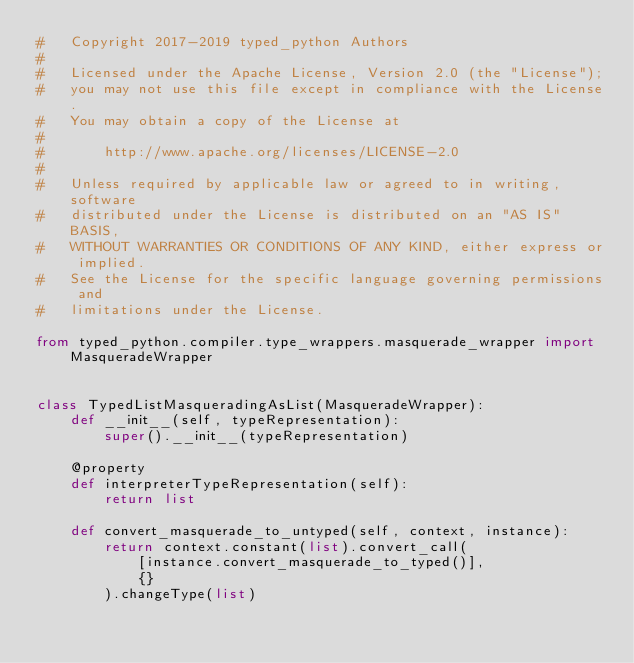<code> <loc_0><loc_0><loc_500><loc_500><_Python_>#   Copyright 2017-2019 typed_python Authors
#
#   Licensed under the Apache License, Version 2.0 (the "License");
#   you may not use this file except in compliance with the License.
#   You may obtain a copy of the License at
#
#       http://www.apache.org/licenses/LICENSE-2.0
#
#   Unless required by applicable law or agreed to in writing, software
#   distributed under the License is distributed on an "AS IS" BASIS,
#   WITHOUT WARRANTIES OR CONDITIONS OF ANY KIND, either express or implied.
#   See the License for the specific language governing permissions and
#   limitations under the License.

from typed_python.compiler.type_wrappers.masquerade_wrapper import MasqueradeWrapper


class TypedListMasqueradingAsList(MasqueradeWrapper):
    def __init__(self, typeRepresentation):
        super().__init__(typeRepresentation)

    @property
    def interpreterTypeRepresentation(self):
        return list

    def convert_masquerade_to_untyped(self, context, instance):
        return context.constant(list).convert_call(
            [instance.convert_masquerade_to_typed()],
            {}
        ).changeType(list)
</code> 